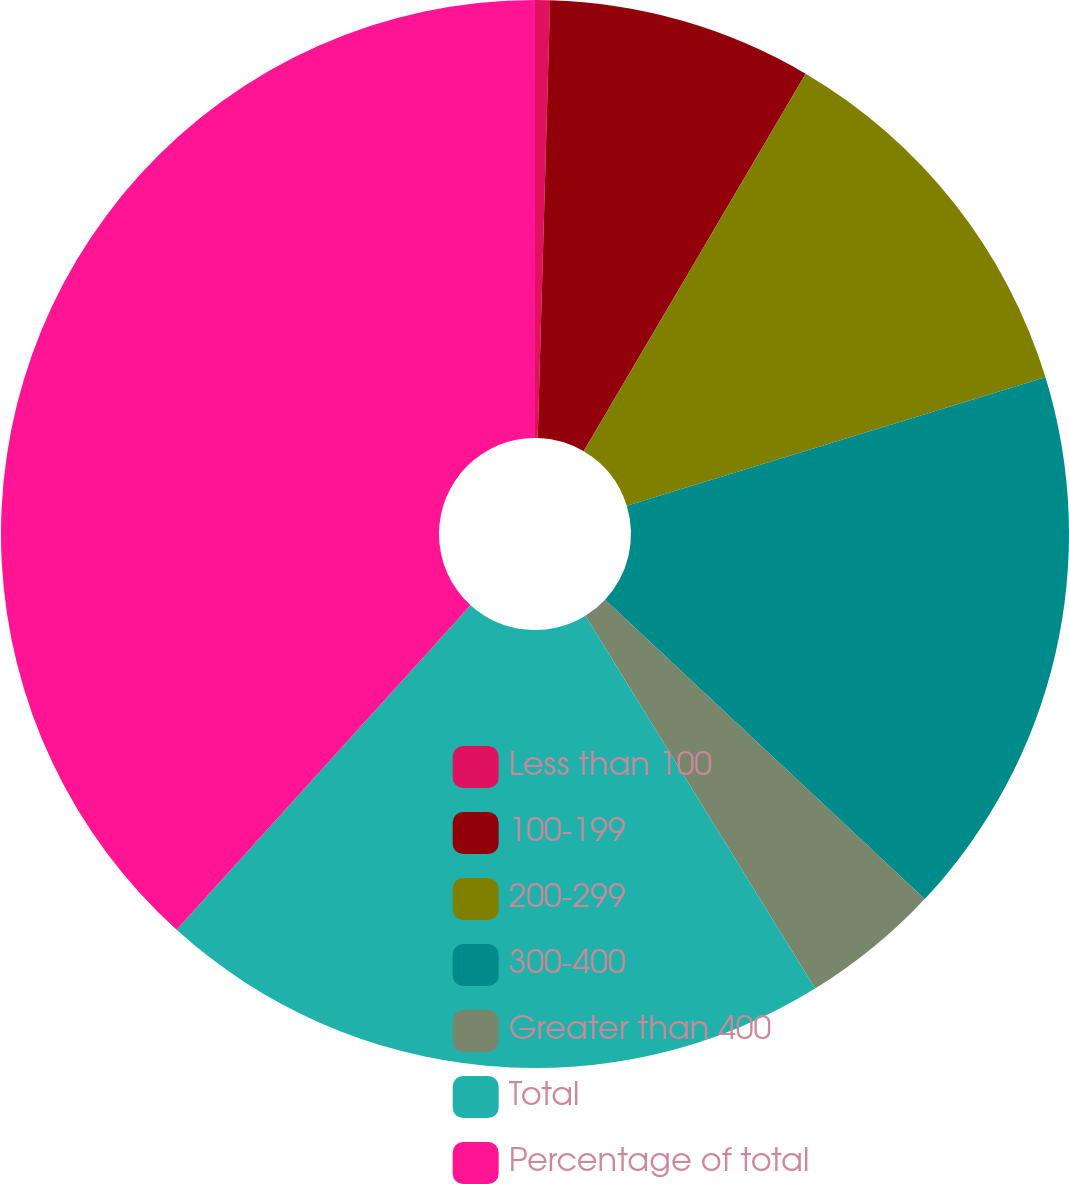Convert chart. <chart><loc_0><loc_0><loc_500><loc_500><pie_chart><fcel>Less than 100<fcel>100-199<fcel>200-299<fcel>300-400<fcel>Greater than 400<fcel>Total<fcel>Percentage of total<nl><fcel>0.45%<fcel>8.01%<fcel>11.8%<fcel>16.72%<fcel>4.23%<fcel>20.5%<fcel>38.29%<nl></chart> 